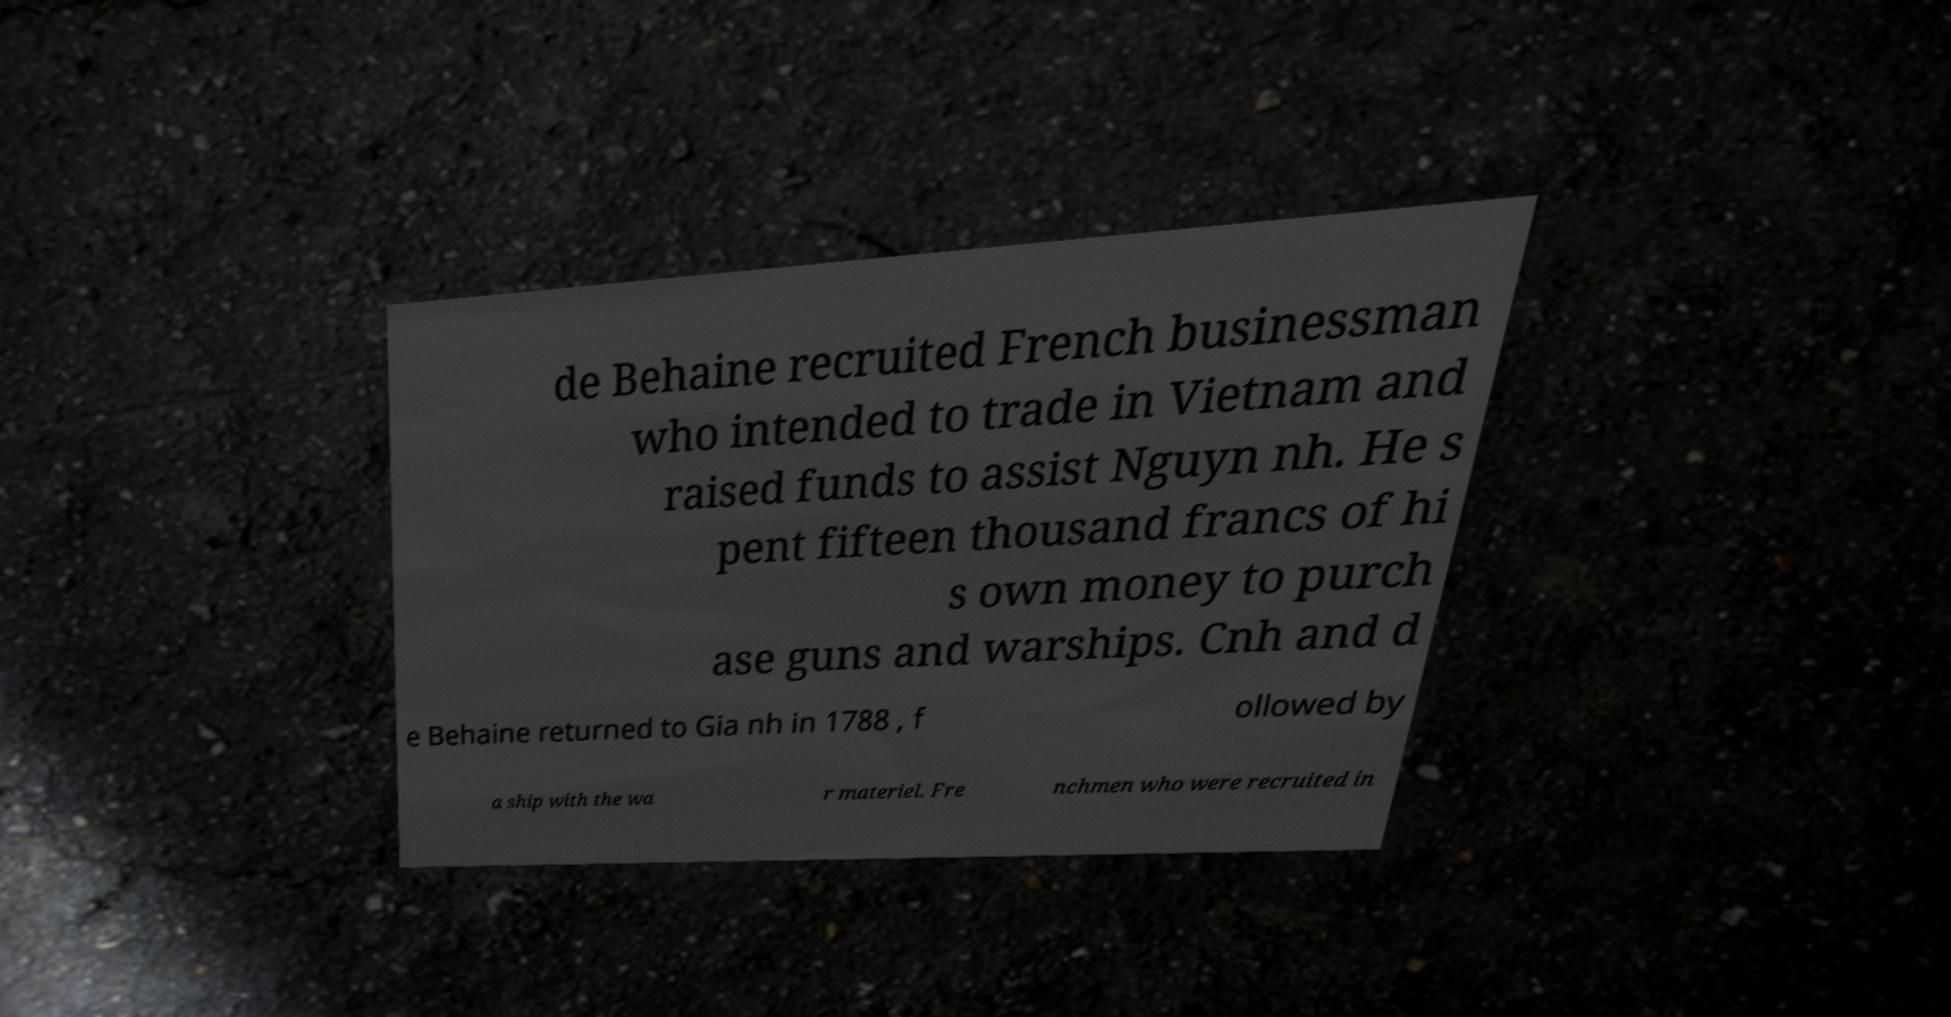For documentation purposes, I need the text within this image transcribed. Could you provide that? de Behaine recruited French businessman who intended to trade in Vietnam and raised funds to assist Nguyn nh. He s pent fifteen thousand francs of hi s own money to purch ase guns and warships. Cnh and d e Behaine returned to Gia nh in 1788 , f ollowed by a ship with the wa r materiel. Fre nchmen who were recruited in 